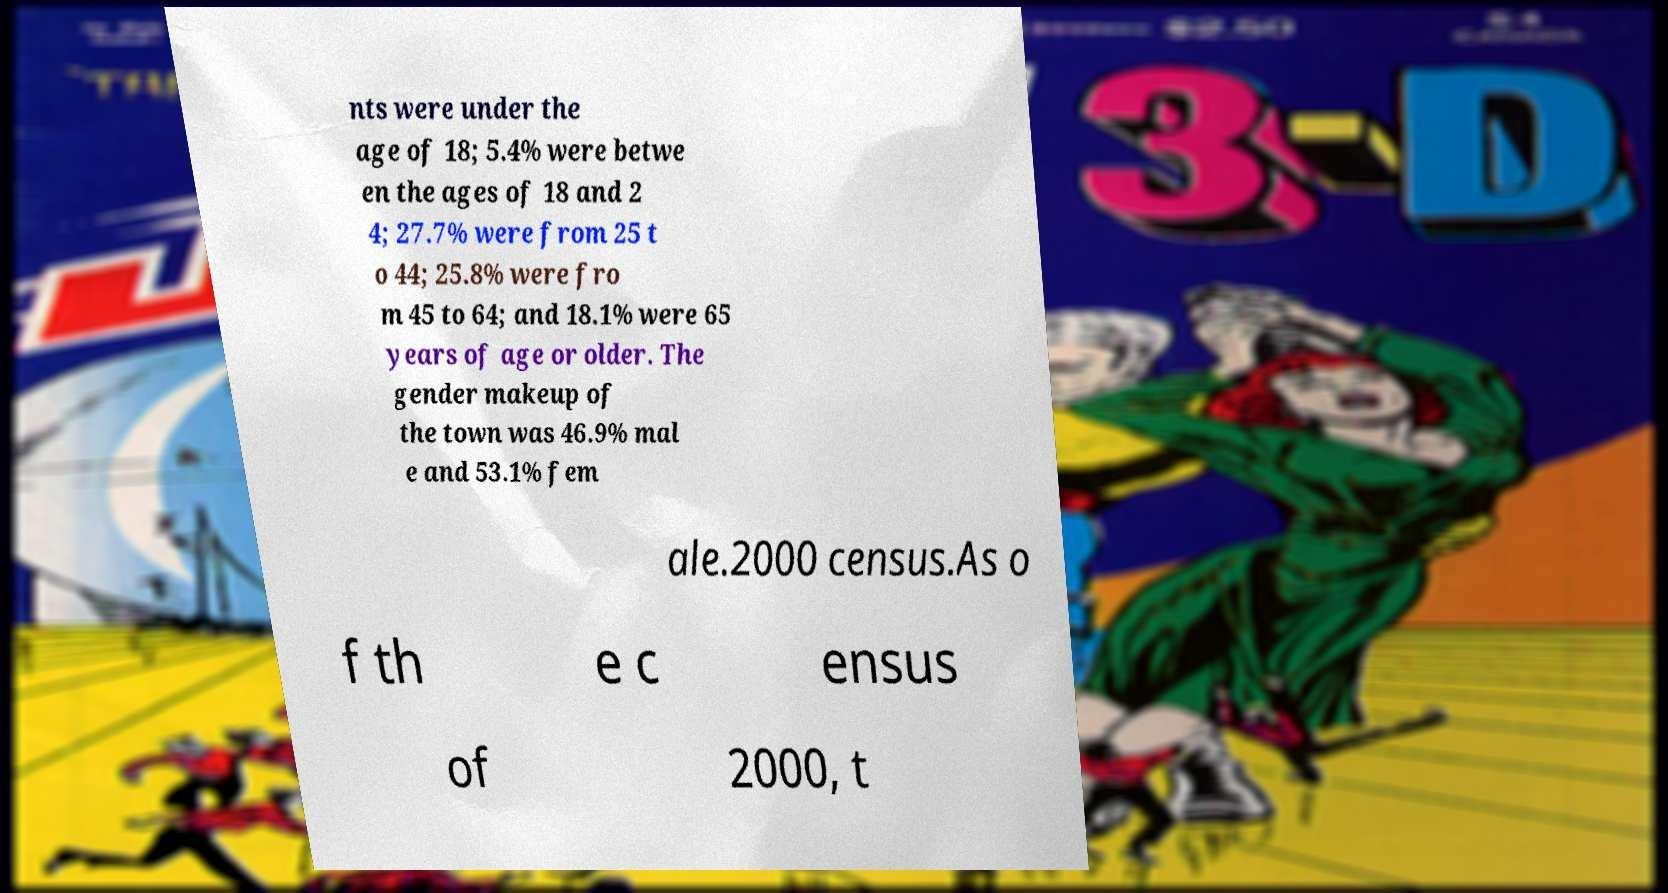There's text embedded in this image that I need extracted. Can you transcribe it verbatim? nts were under the age of 18; 5.4% were betwe en the ages of 18 and 2 4; 27.7% were from 25 t o 44; 25.8% were fro m 45 to 64; and 18.1% were 65 years of age or older. The gender makeup of the town was 46.9% mal e and 53.1% fem ale.2000 census.As o f th e c ensus of 2000, t 